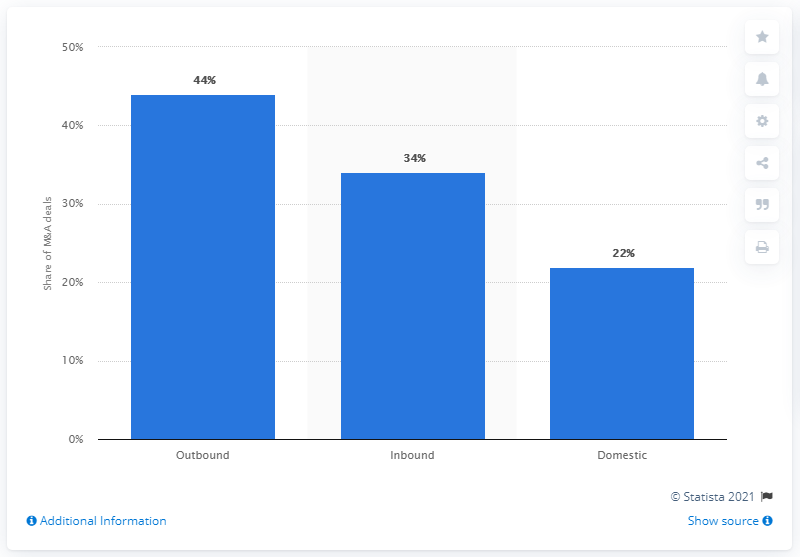List a handful of essential elements in this visual. In terms of value, 44% of all outbound M&A deals were in the UK in 2019. 